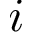<formula> <loc_0><loc_0><loc_500><loc_500>i</formula> 